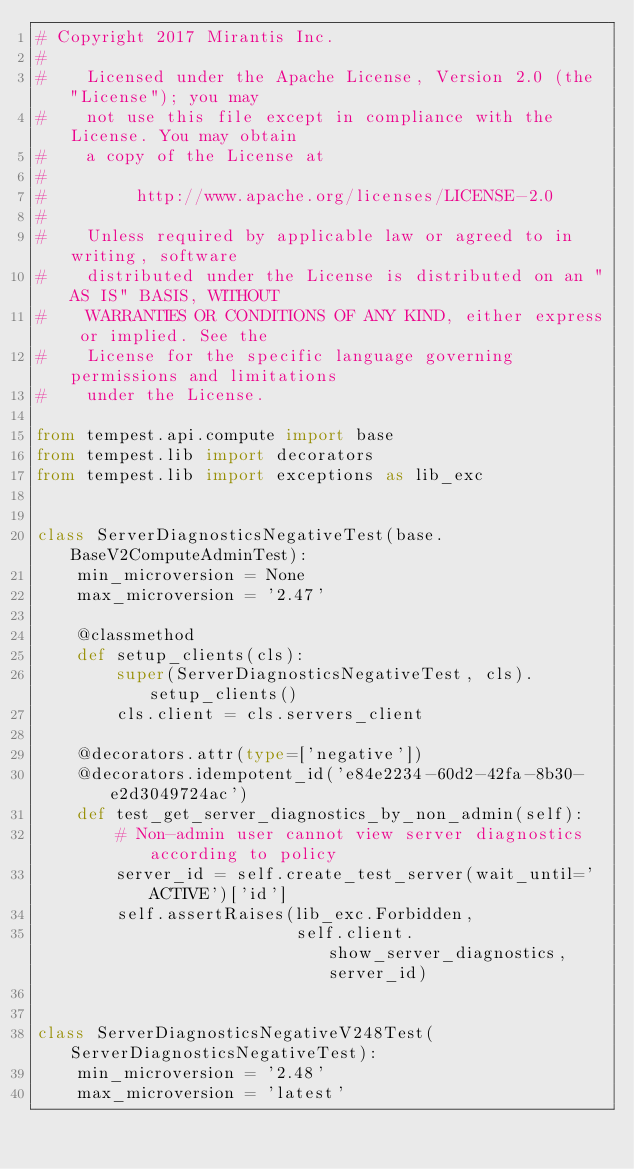Convert code to text. <code><loc_0><loc_0><loc_500><loc_500><_Python_># Copyright 2017 Mirantis Inc.
#
#    Licensed under the Apache License, Version 2.0 (the "License"); you may
#    not use this file except in compliance with the License. You may obtain
#    a copy of the License at
#
#         http://www.apache.org/licenses/LICENSE-2.0
#
#    Unless required by applicable law or agreed to in writing, software
#    distributed under the License is distributed on an "AS IS" BASIS, WITHOUT
#    WARRANTIES OR CONDITIONS OF ANY KIND, either express or implied. See the
#    License for the specific language governing permissions and limitations
#    under the License.

from tempest.api.compute import base
from tempest.lib import decorators
from tempest.lib import exceptions as lib_exc


class ServerDiagnosticsNegativeTest(base.BaseV2ComputeAdminTest):
    min_microversion = None
    max_microversion = '2.47'

    @classmethod
    def setup_clients(cls):
        super(ServerDiagnosticsNegativeTest, cls).setup_clients()
        cls.client = cls.servers_client

    @decorators.attr(type=['negative'])
    @decorators.idempotent_id('e84e2234-60d2-42fa-8b30-e2d3049724ac')
    def test_get_server_diagnostics_by_non_admin(self):
        # Non-admin user cannot view server diagnostics according to policy
        server_id = self.create_test_server(wait_until='ACTIVE')['id']
        self.assertRaises(lib_exc.Forbidden,
                          self.client.show_server_diagnostics, server_id)


class ServerDiagnosticsNegativeV248Test(ServerDiagnosticsNegativeTest):
    min_microversion = '2.48'
    max_microversion = 'latest'
</code> 